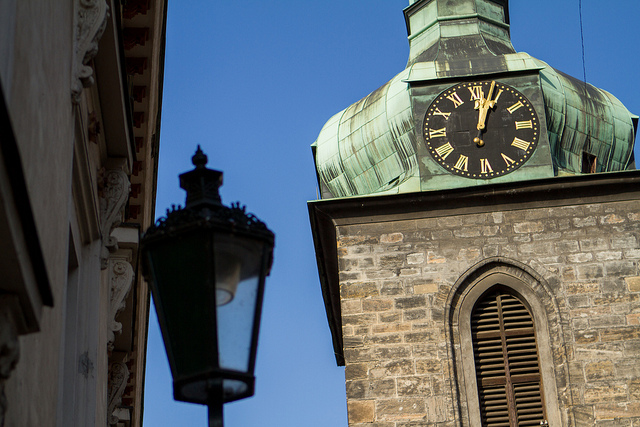<image>Who invented the idea of Time? It is ambiguous who invented the idea of time. It could be ancient people, humans, Einstein or even 'Father Time'. Who invented the idea of Time? I don't know who invented the idea of Time. It is a concept that has been understood and contemplated by humans for a long time. Some believe it is a natural phenomenon, while others attribute it to a higher power like God. 